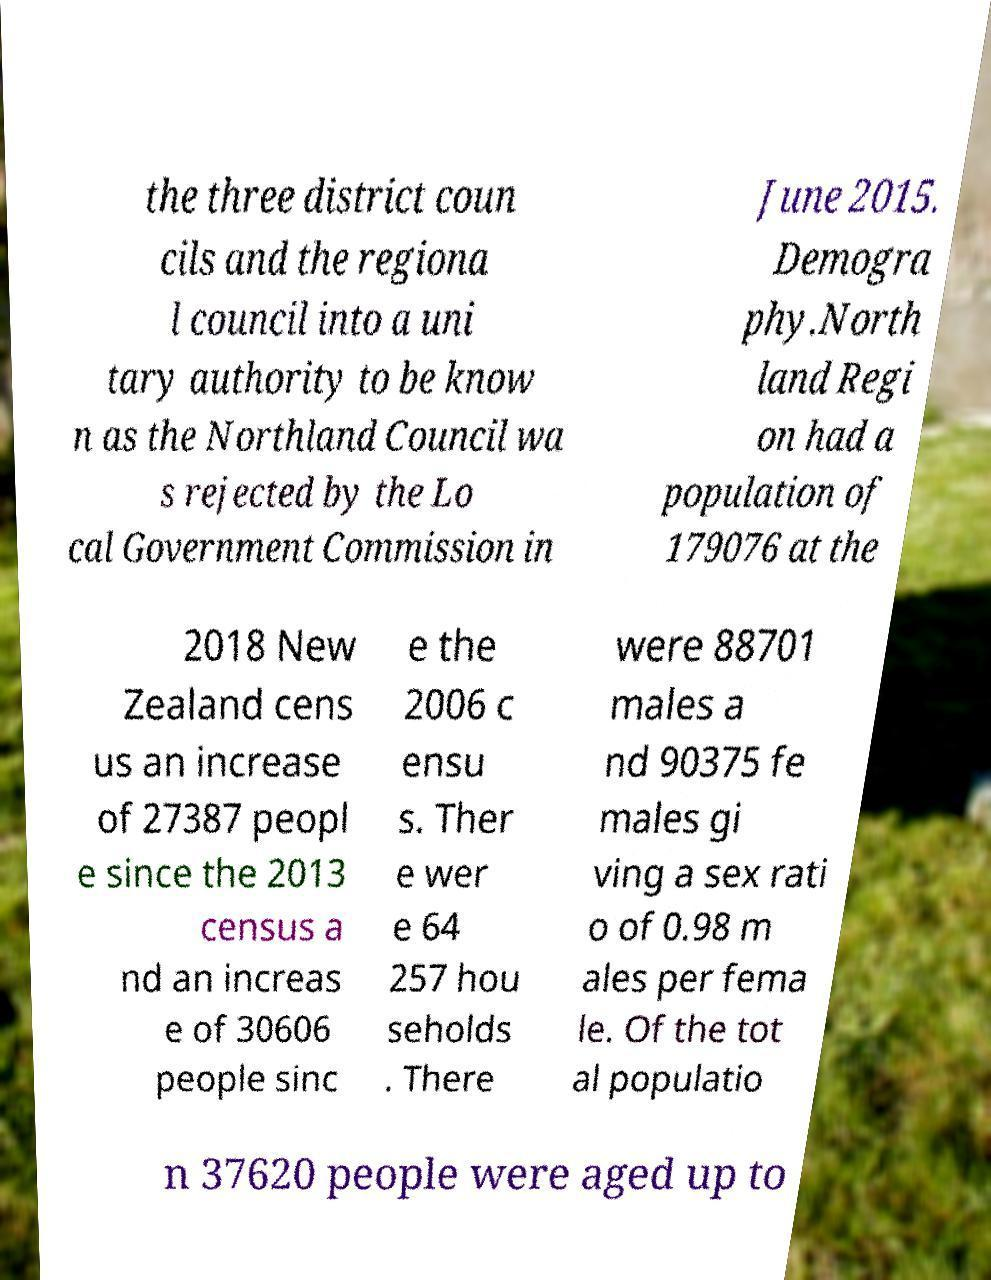Can you accurately transcribe the text from the provided image for me? the three district coun cils and the regiona l council into a uni tary authority to be know n as the Northland Council wa s rejected by the Lo cal Government Commission in June 2015. Demogra phy.North land Regi on had a population of 179076 at the 2018 New Zealand cens us an increase of 27387 peopl e since the 2013 census a nd an increas e of 30606 people sinc e the 2006 c ensu s. Ther e wer e 64 257 hou seholds . There were 88701 males a nd 90375 fe males gi ving a sex rati o of 0.98 m ales per fema le. Of the tot al populatio n 37620 people were aged up to 